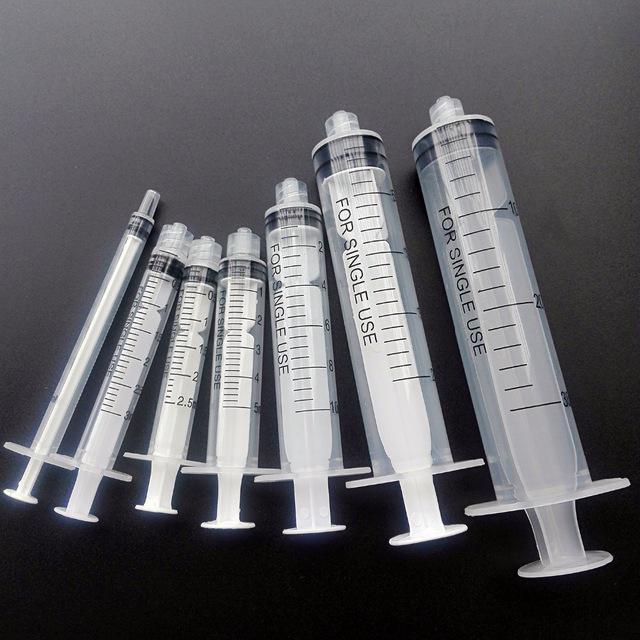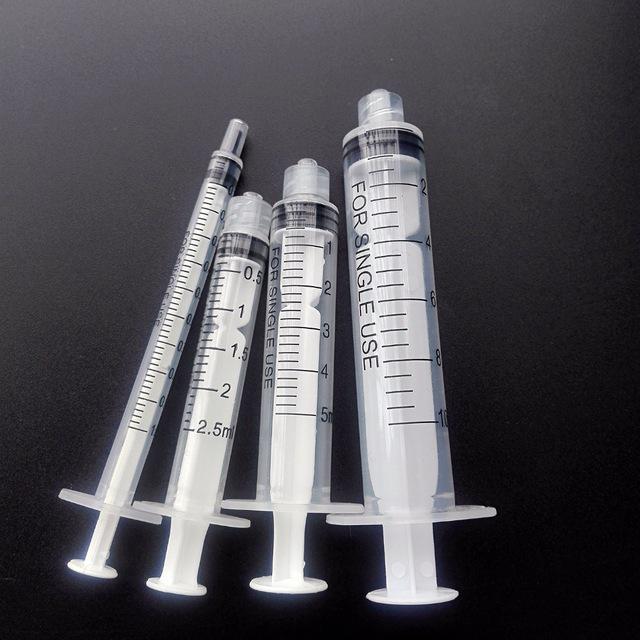The first image is the image on the left, the second image is the image on the right. Considering the images on both sides, is "The left image shows a single syringe with needle attached." valid? Answer yes or no. No. 